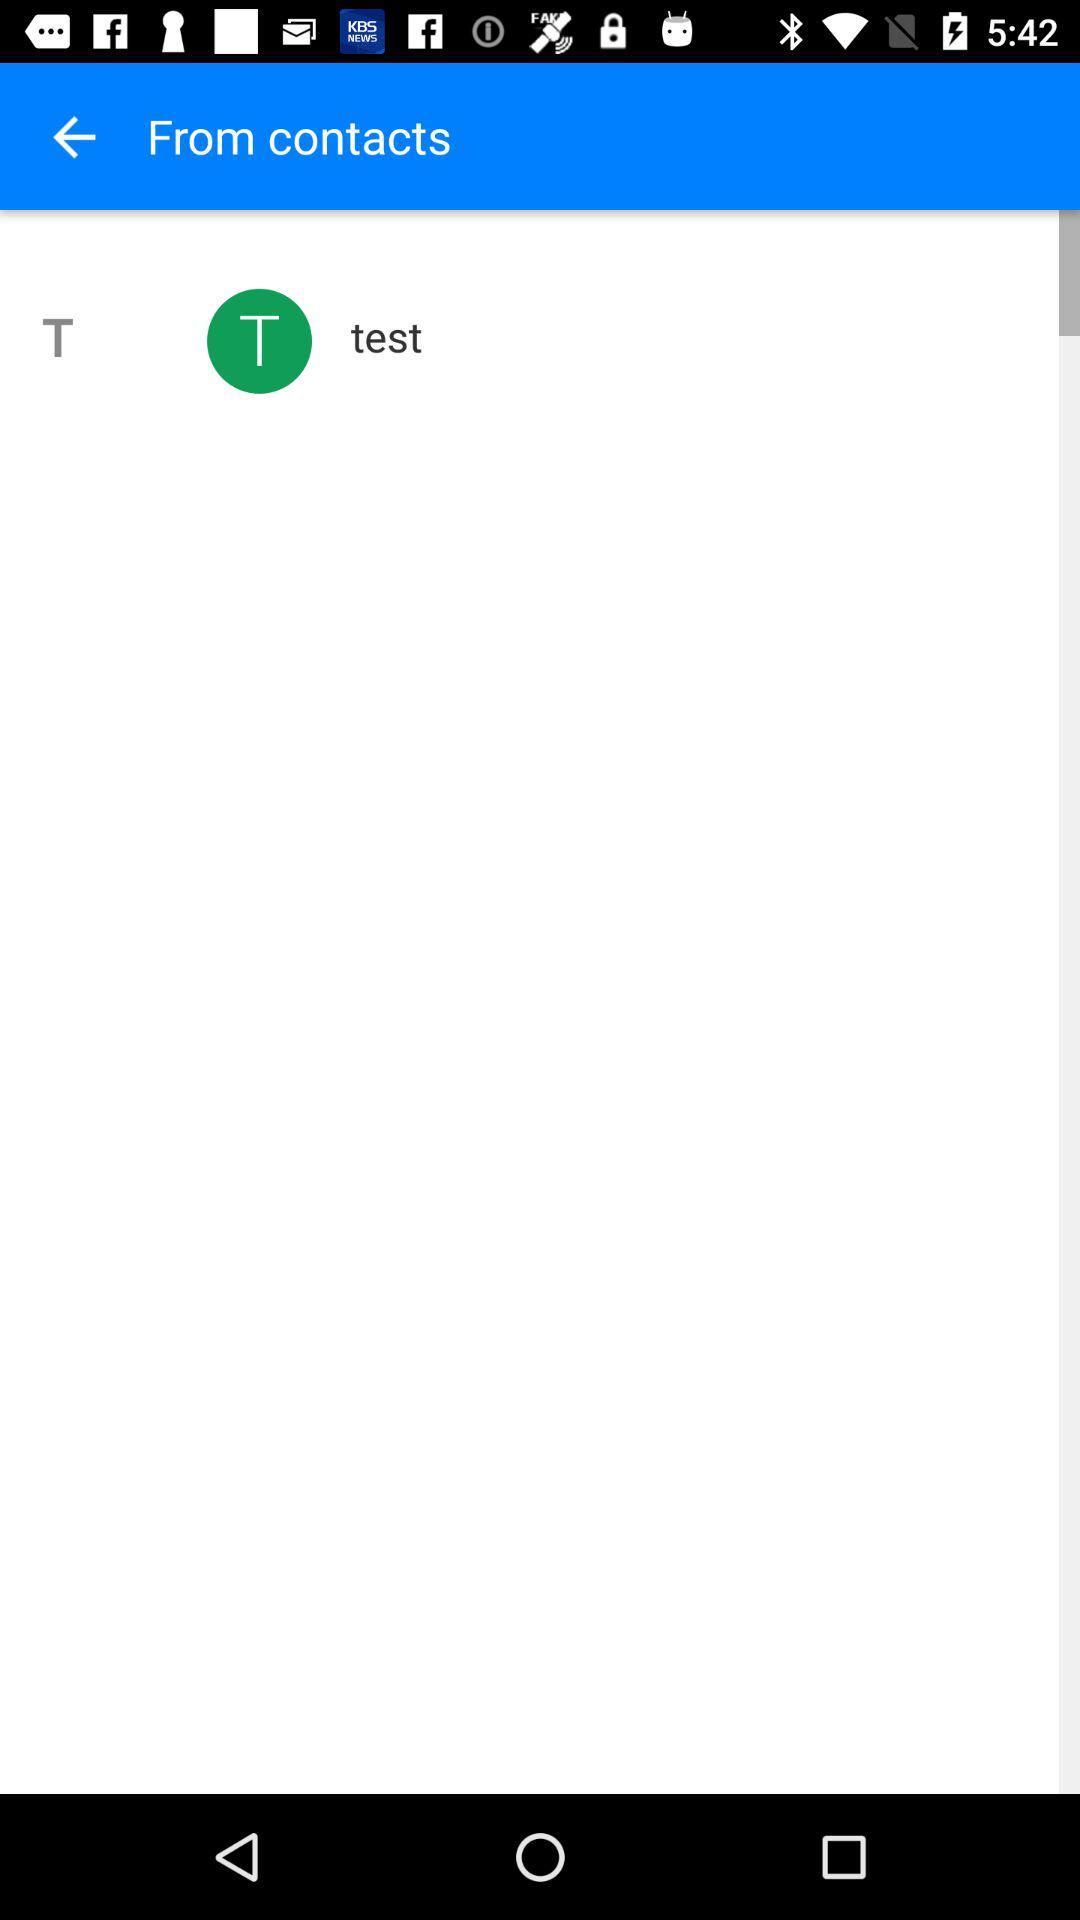What contact name is shown on the screen? The contact name shown on the screen is Test. 